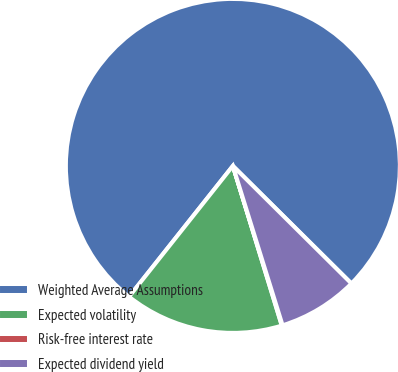<chart> <loc_0><loc_0><loc_500><loc_500><pie_chart><fcel>Weighted Average Assumptions<fcel>Expected volatility<fcel>Risk-free interest rate<fcel>Expected dividend yield<nl><fcel>76.76%<fcel>15.41%<fcel>0.08%<fcel>7.75%<nl></chart> 